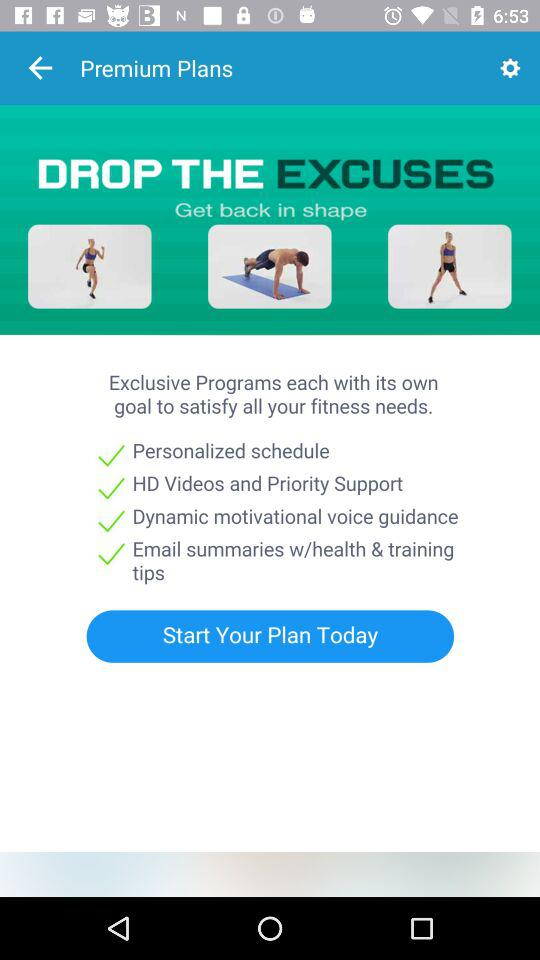What is the application name? The application name is "Get back in shape". 